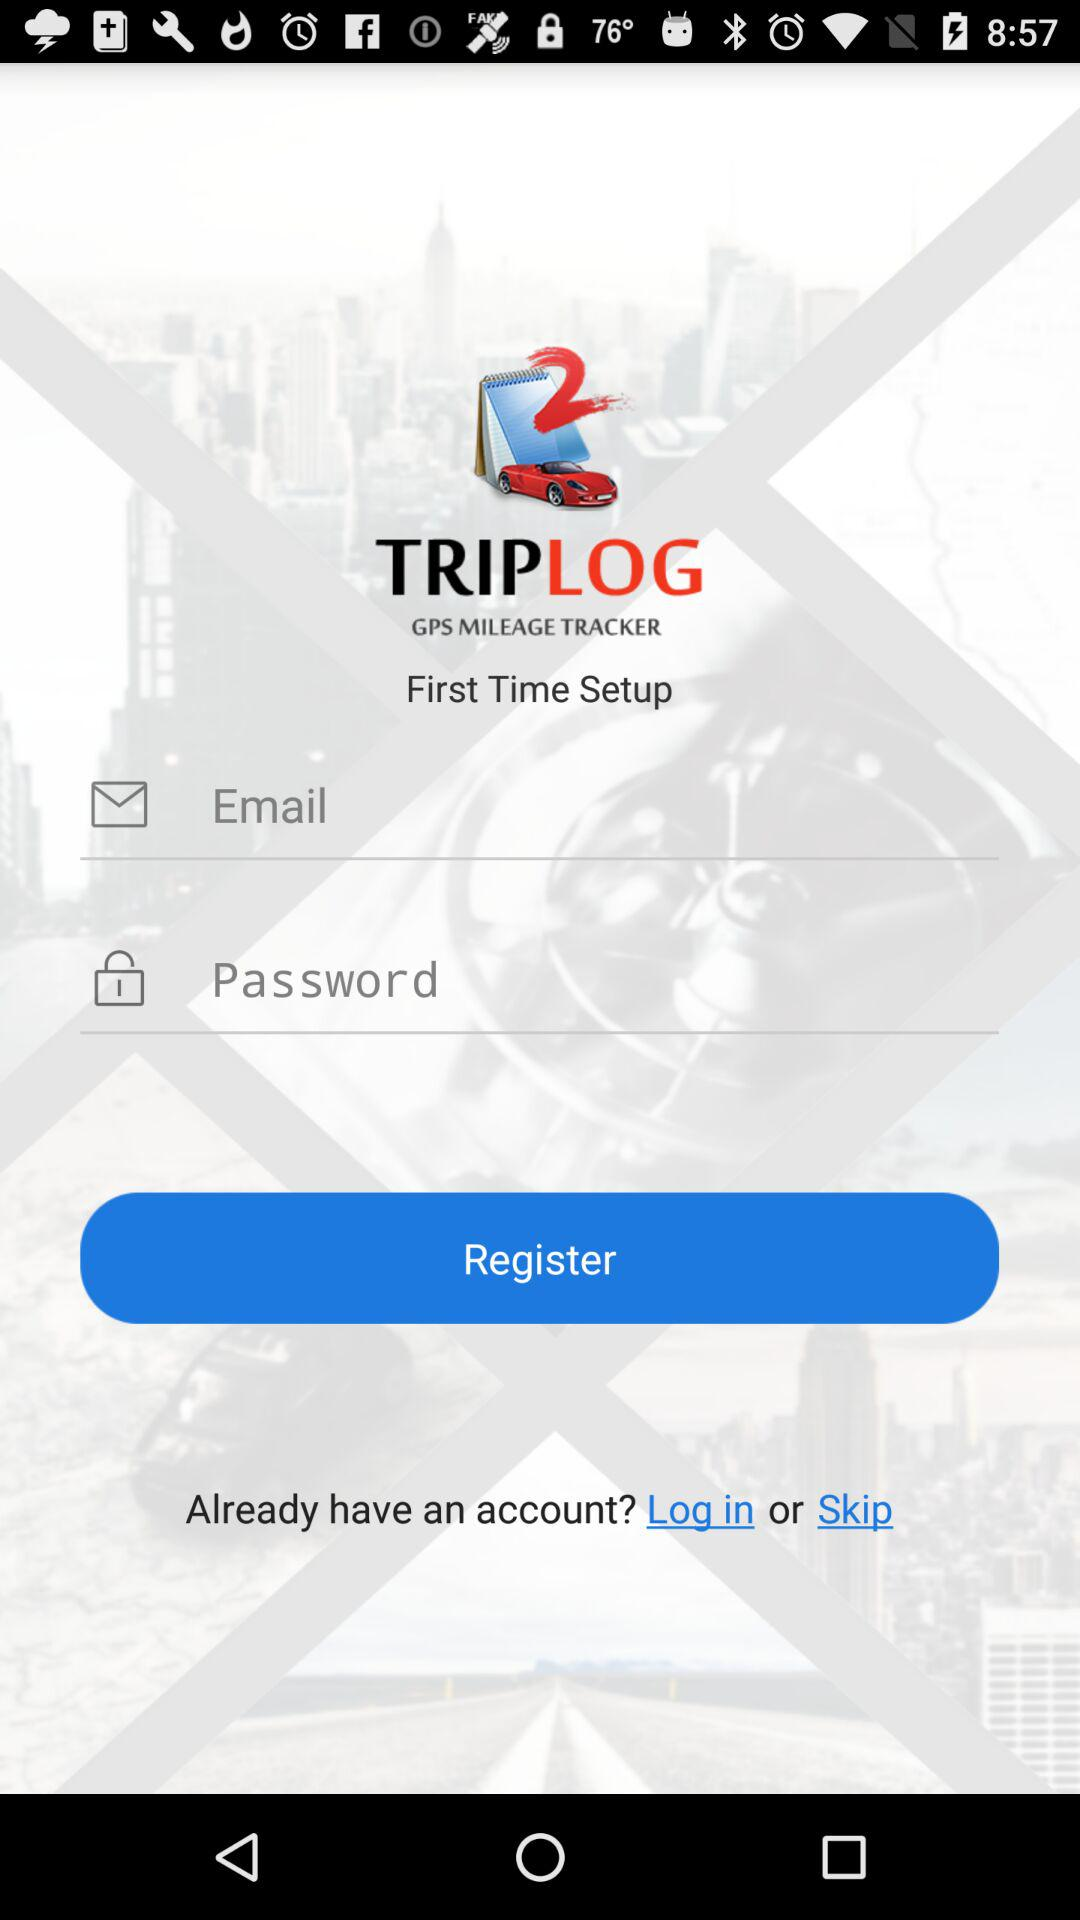What is the application name? The application name is "TRIPLOG GPS MILEAGE TRACKER". 